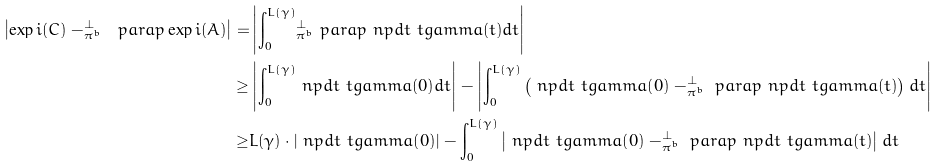<formula> <loc_0><loc_0><loc_500><loc_500>\left | \exp i ( C ) - _ { \pi ^ { b } } ^ { \perp } \ p a r a p \exp i ( A ) \right | = & \left | { \int _ { 0 } ^ { L ( \gamma ) } } { _ { \pi ^ { b } } ^ { \perp } \ p a r a p } \ n p d t \ t g a m m a ( t ) d t \right | \\ \geq & \left | { \int _ { 0 } ^ { L ( \gamma ) } } \ n p d t \ t g a m m a ( 0 ) d t \right | - \left | { \int _ { 0 } ^ { L ( \gamma ) } } \left ( \ n p d t \ t g a m m a ( 0 ) - _ { \pi ^ { b } } ^ { \perp } \ p a r a p \ n p d t \ t g a m m a ( t ) \right ) d t \right | \\ \geq & L ( \gamma ) \cdot \left | \ n p d t \ t g a m m a ( 0 ) \right | - { \int _ { 0 } ^ { L ( \gamma ) } } \left | \ n p d t \ t g a m m a ( 0 ) - _ { \pi ^ { b } } ^ { \perp } \ p a r a p \ n p d t \ t g a m m a ( t ) \right | d t</formula> 